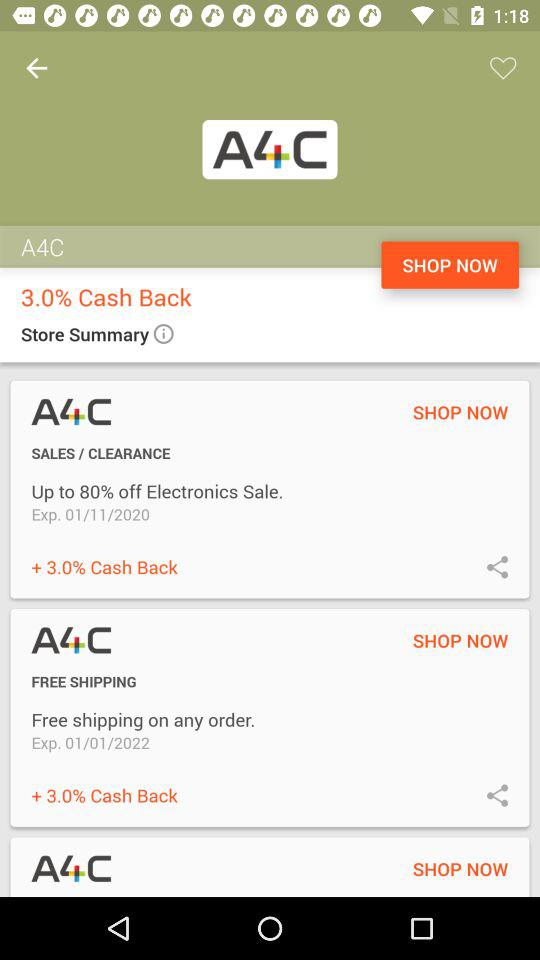What is the expiration date of the 80% off electronics sale? The expiration date of the 80% off electronic sale is January 11, 2020. 